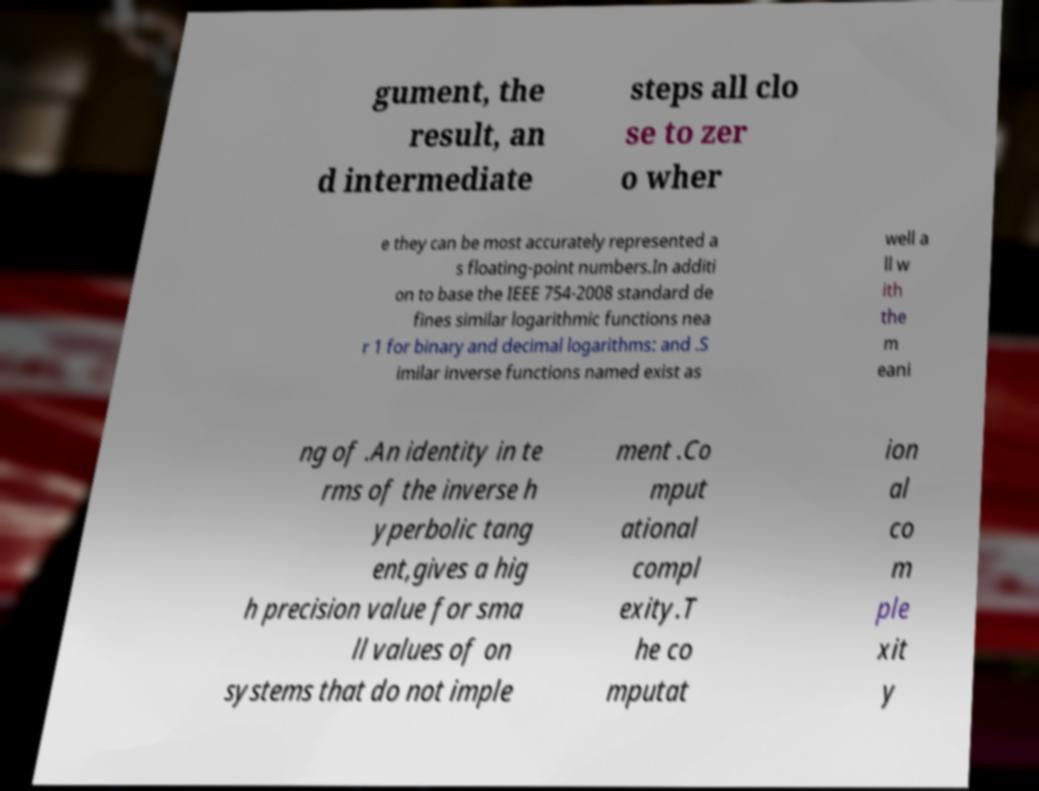I need the written content from this picture converted into text. Can you do that? gument, the result, an d intermediate steps all clo se to zer o wher e they can be most accurately represented a s floating-point numbers.In additi on to base the IEEE 754-2008 standard de fines similar logarithmic functions nea r 1 for binary and decimal logarithms: and .S imilar inverse functions named exist as well a ll w ith the m eani ng of .An identity in te rms of the inverse h yperbolic tang ent,gives a hig h precision value for sma ll values of on systems that do not imple ment .Co mput ational compl exity.T he co mputat ion al co m ple xit y 